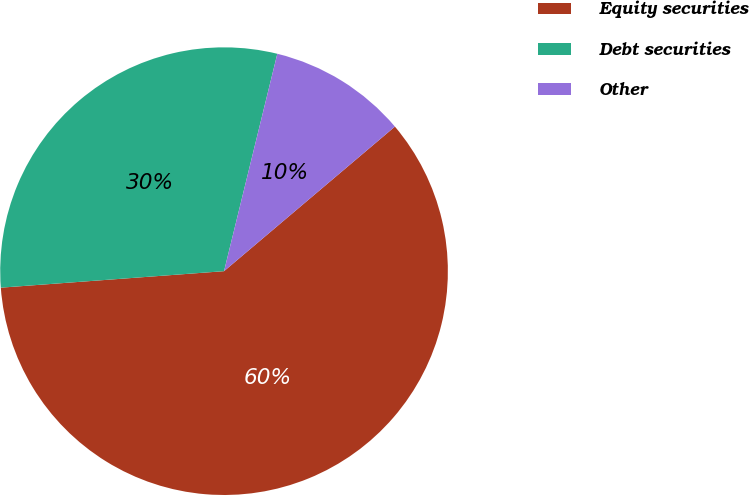Convert chart. <chart><loc_0><loc_0><loc_500><loc_500><pie_chart><fcel>Equity securities<fcel>Debt securities<fcel>Other<nl><fcel>60.0%<fcel>30.0%<fcel>10.0%<nl></chart> 